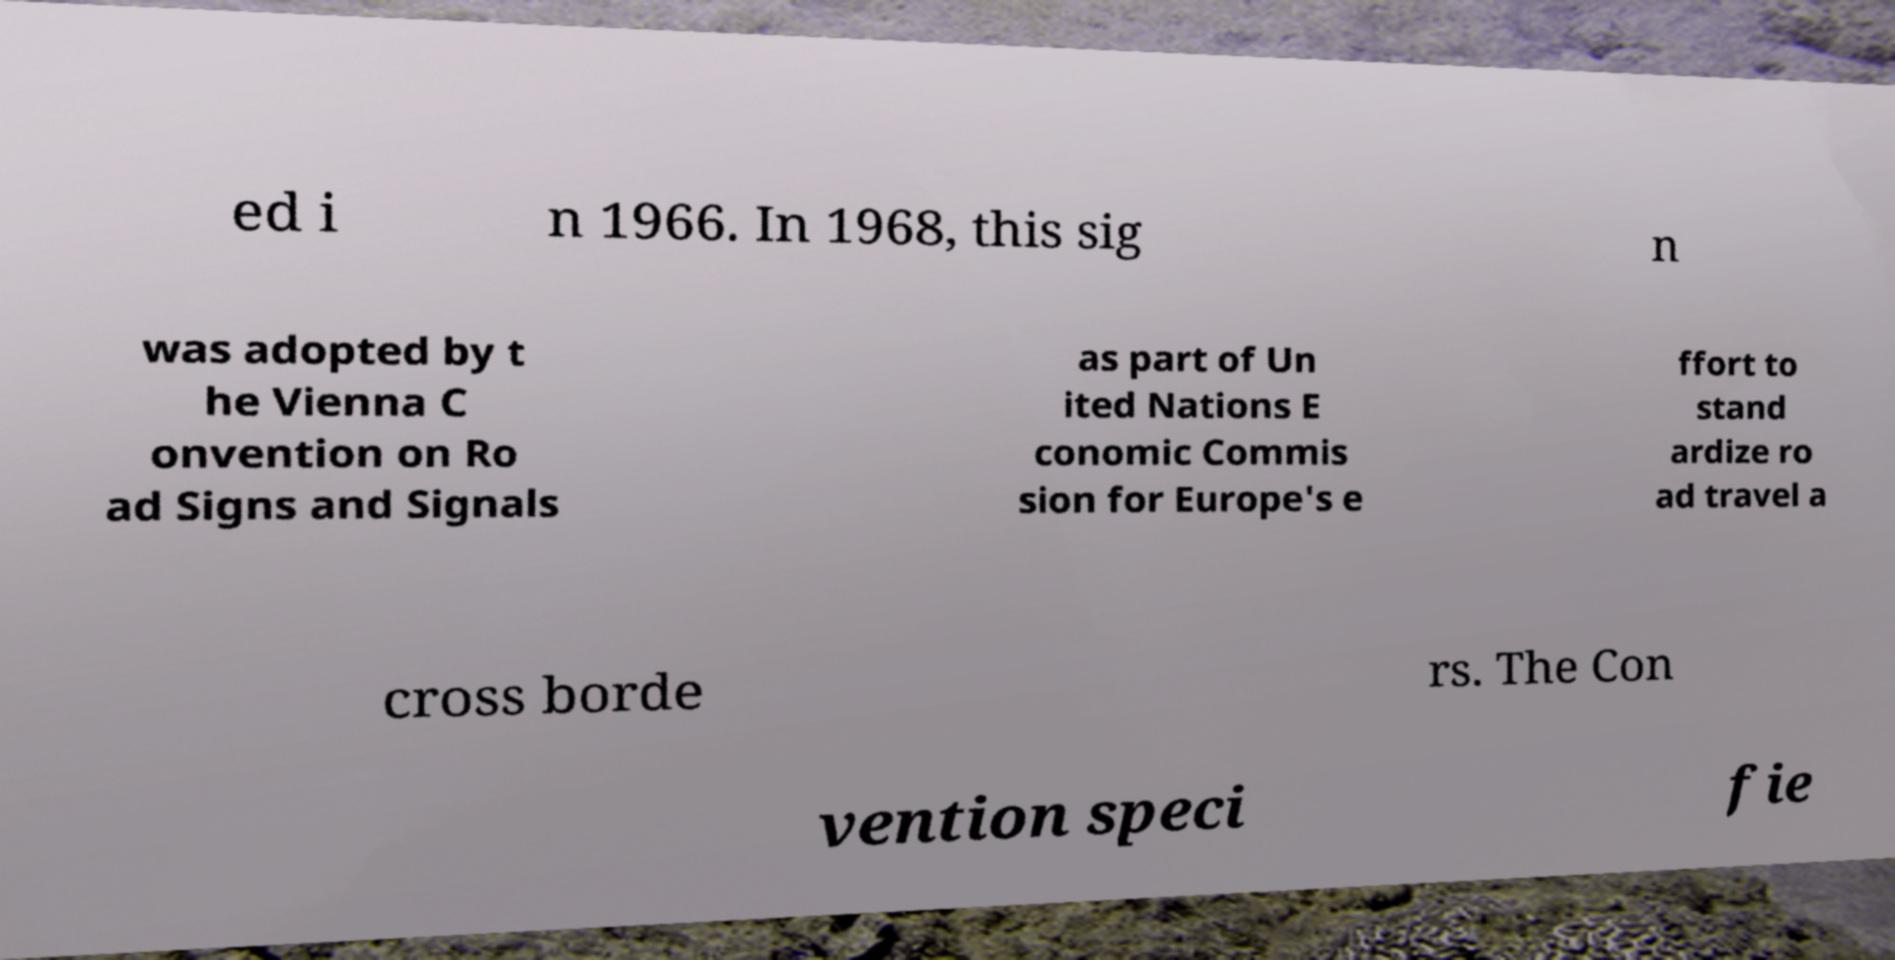Can you read and provide the text displayed in the image?This photo seems to have some interesting text. Can you extract and type it out for me? ed i n 1966. In 1968, this sig n was adopted by t he Vienna C onvention on Ro ad Signs and Signals as part of Un ited Nations E conomic Commis sion for Europe's e ffort to stand ardize ro ad travel a cross borde rs. The Con vention speci fie 